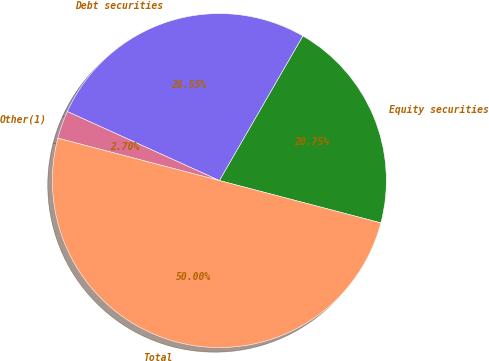<chart> <loc_0><loc_0><loc_500><loc_500><pie_chart><fcel>Equity securities<fcel>Debt securities<fcel>Other(1)<fcel>Total<nl><fcel>20.75%<fcel>26.55%<fcel>2.7%<fcel>50.0%<nl></chart> 